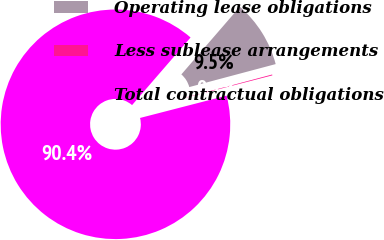<chart> <loc_0><loc_0><loc_500><loc_500><pie_chart><fcel>Operating lease obligations<fcel>Less sublease arrangements<fcel>Total contractual obligations<nl><fcel>9.51%<fcel>0.12%<fcel>90.36%<nl></chart> 